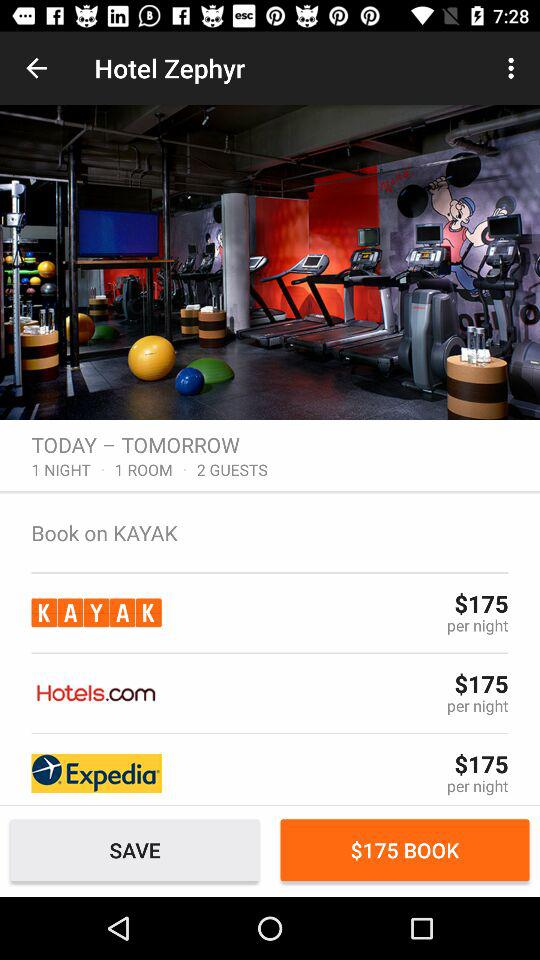What is the number of rooms? The number of rooms is 1. 